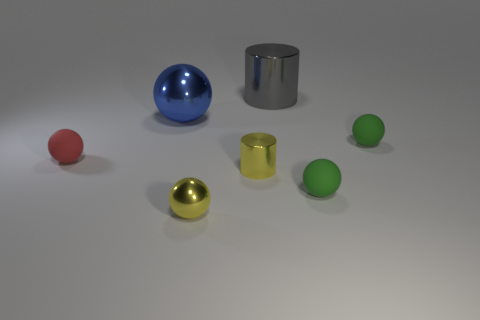Are there fewer small red matte balls behind the small red sphere than small yellow cylinders left of the large gray metal cylinder?
Make the answer very short. Yes. How many shiny objects are gray cylinders or purple objects?
Your answer should be compact. 1. The blue thing is what shape?
Provide a succinct answer. Sphere. There is a red object that is the same size as the yellow metallic cylinder; what is it made of?
Make the answer very short. Rubber. What number of tiny things are rubber spheres or red spheres?
Give a very brief answer. 3. Are there any large blue metal cubes?
Provide a succinct answer. No. The yellow ball that is the same material as the big gray thing is what size?
Offer a terse response. Small. Is the material of the big ball the same as the small red thing?
Offer a terse response. No. How many other objects are the same material as the blue ball?
Ensure brevity in your answer.  3. How many things are right of the blue thing and behind the yellow metal cylinder?
Give a very brief answer. 2. 